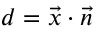<formula> <loc_0><loc_0><loc_500><loc_500>d = { \vec { x } } \cdot { \vec { n } }</formula> 